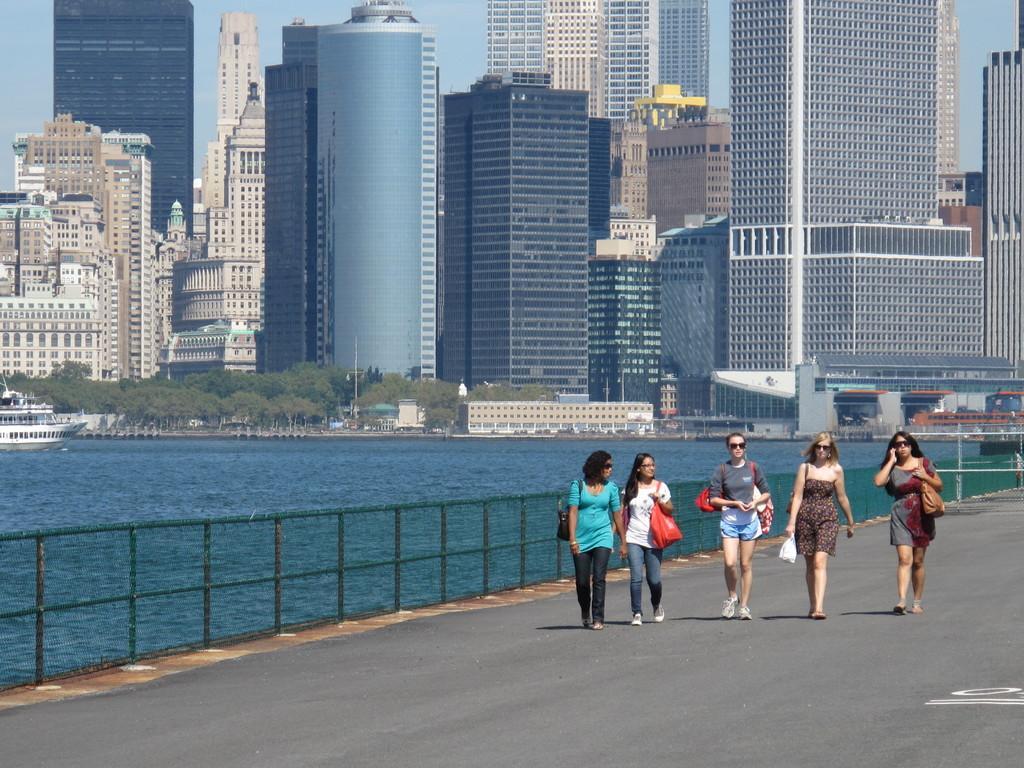Describe this image in one or two sentences. In the image there are few women walking on the road, beside them there is a lake with buildings in the background with trees in front of it and above its sky. 